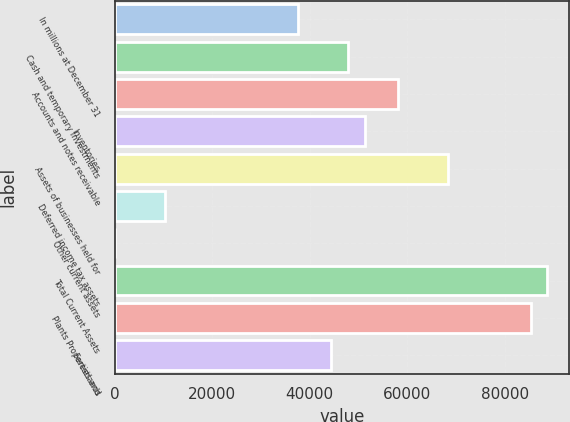Convert chart. <chart><loc_0><loc_0><loc_500><loc_500><bar_chart><fcel>In millions at December 31<fcel>Cash and temporary investments<fcel>Accounts and notes receivable<fcel>Inventories<fcel>Assets of businesses held for<fcel>Deferred income tax assets<fcel>Other current assets<fcel>Total Current Assets<fcel>Plants Properties and<fcel>Forestlands<nl><fcel>37623.4<fcel>47842.6<fcel>58061.8<fcel>51249<fcel>68281<fcel>10372.2<fcel>153<fcel>88719.4<fcel>85313<fcel>44436.2<nl></chart> 